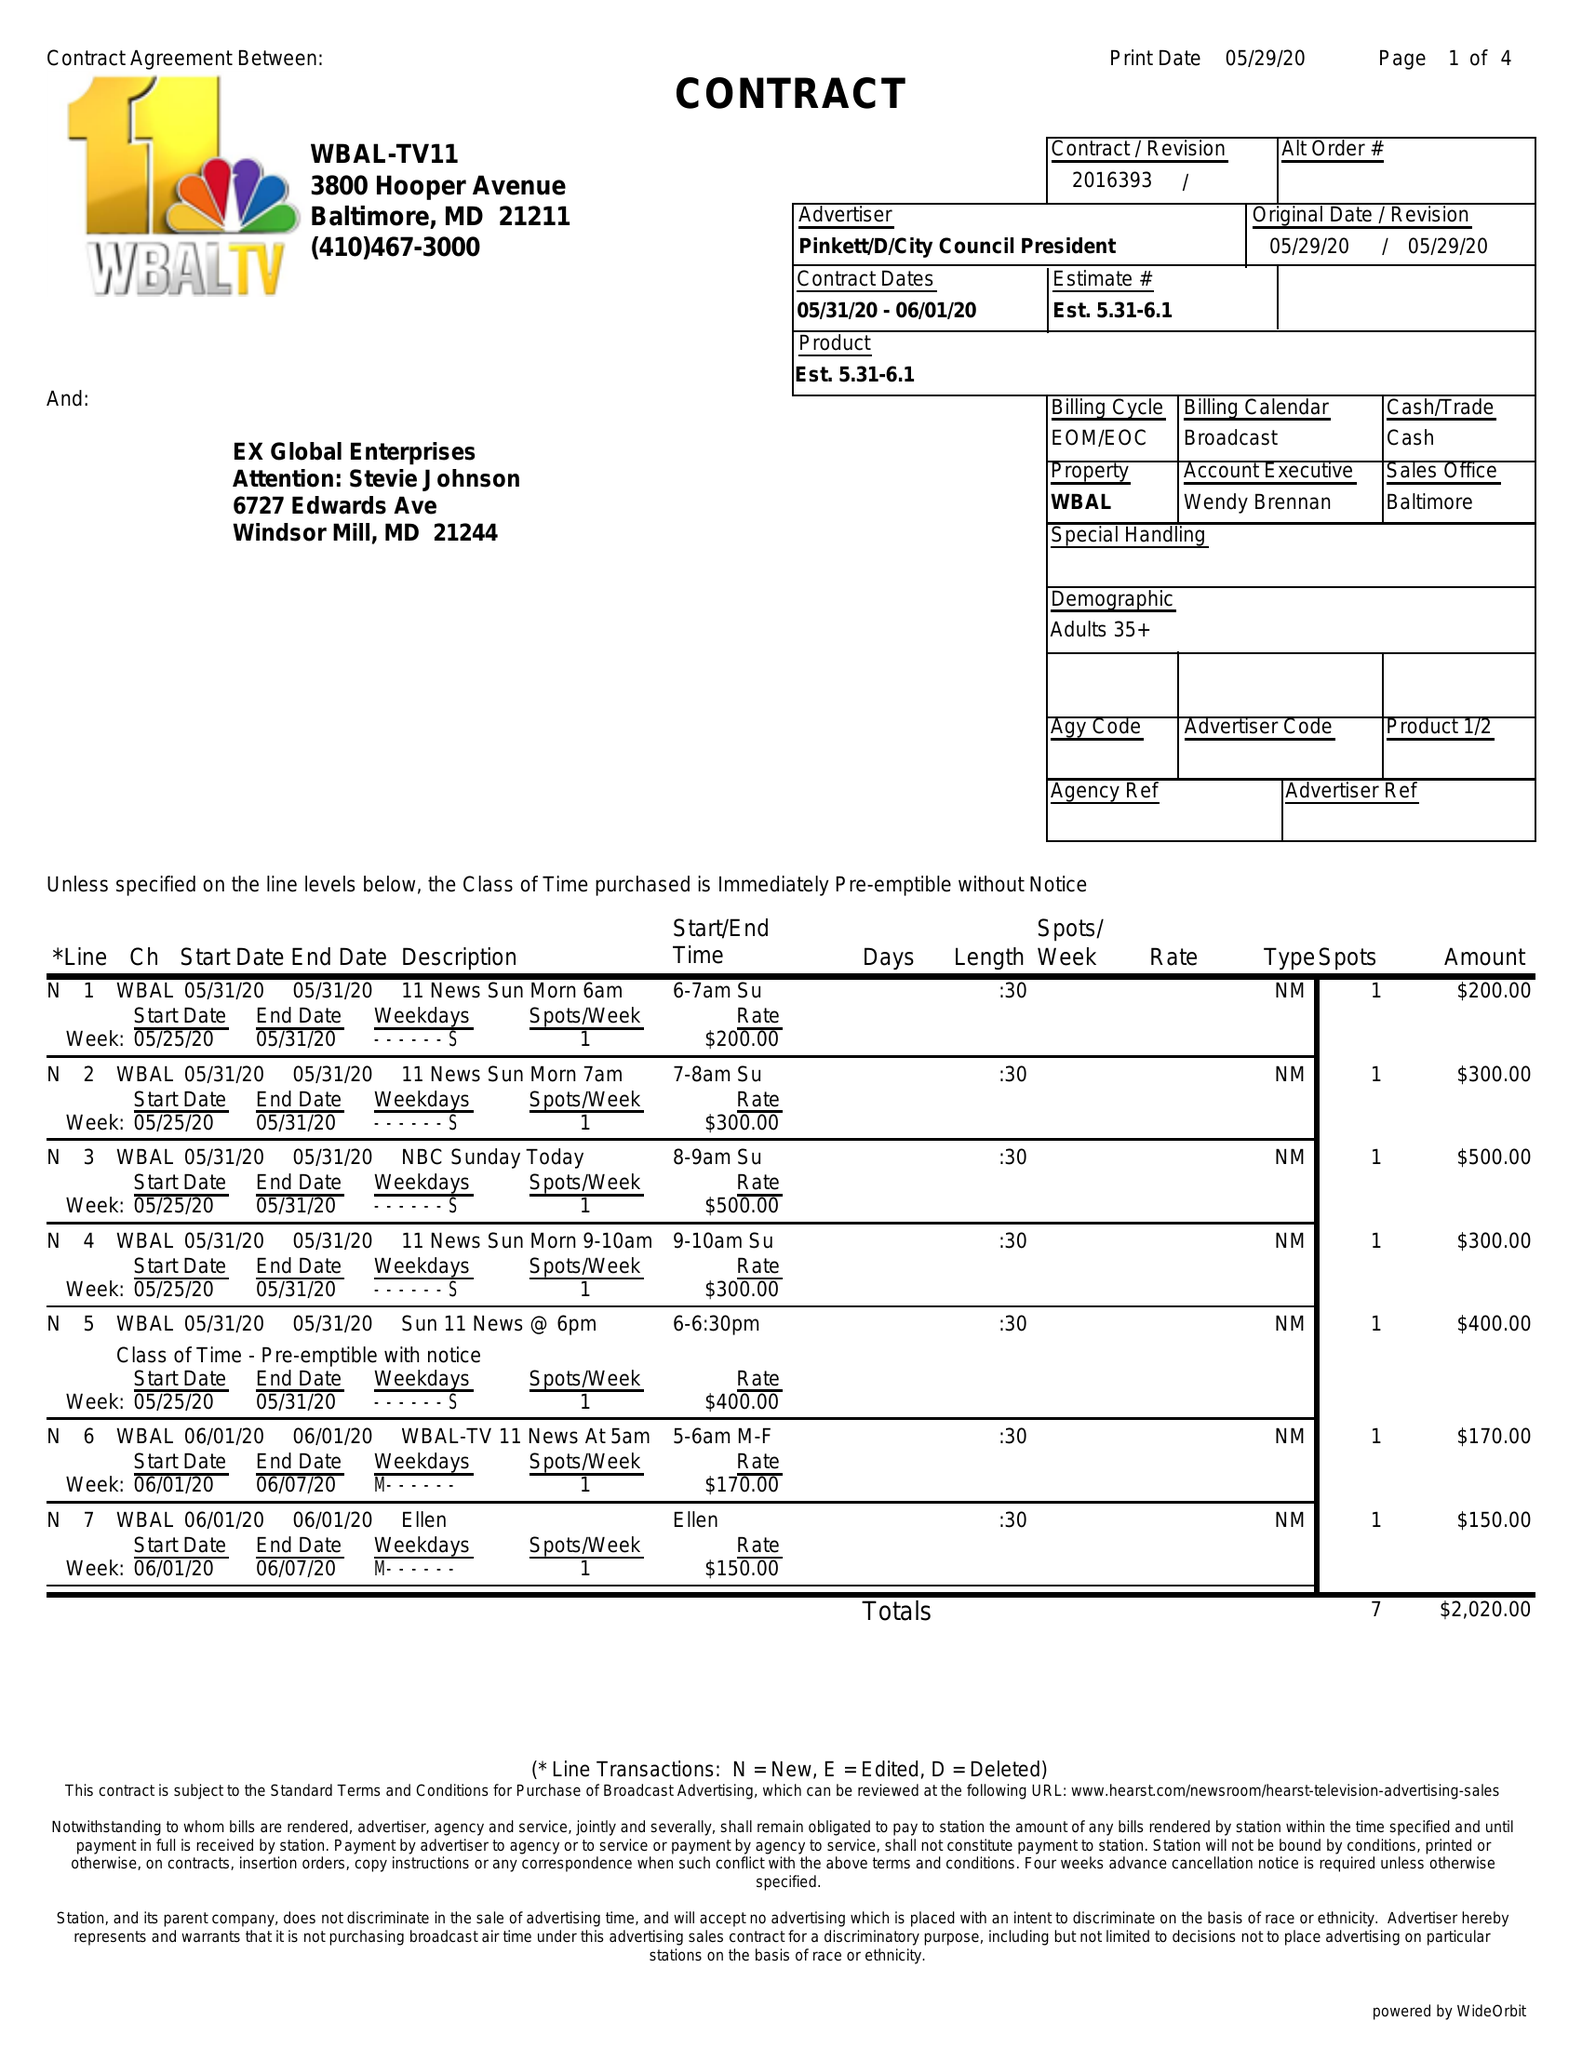What is the value for the advertiser?
Answer the question using a single word or phrase. PINKETT/D/CITYCOUNCILPRESIDENT 